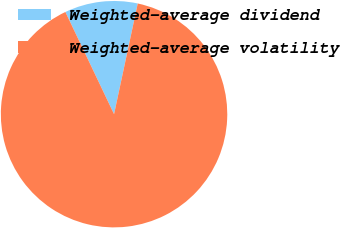Convert chart to OTSL. <chart><loc_0><loc_0><loc_500><loc_500><pie_chart><fcel>Weighted-average dividend<fcel>Weighted-average volatility<nl><fcel>10.43%<fcel>89.57%<nl></chart> 